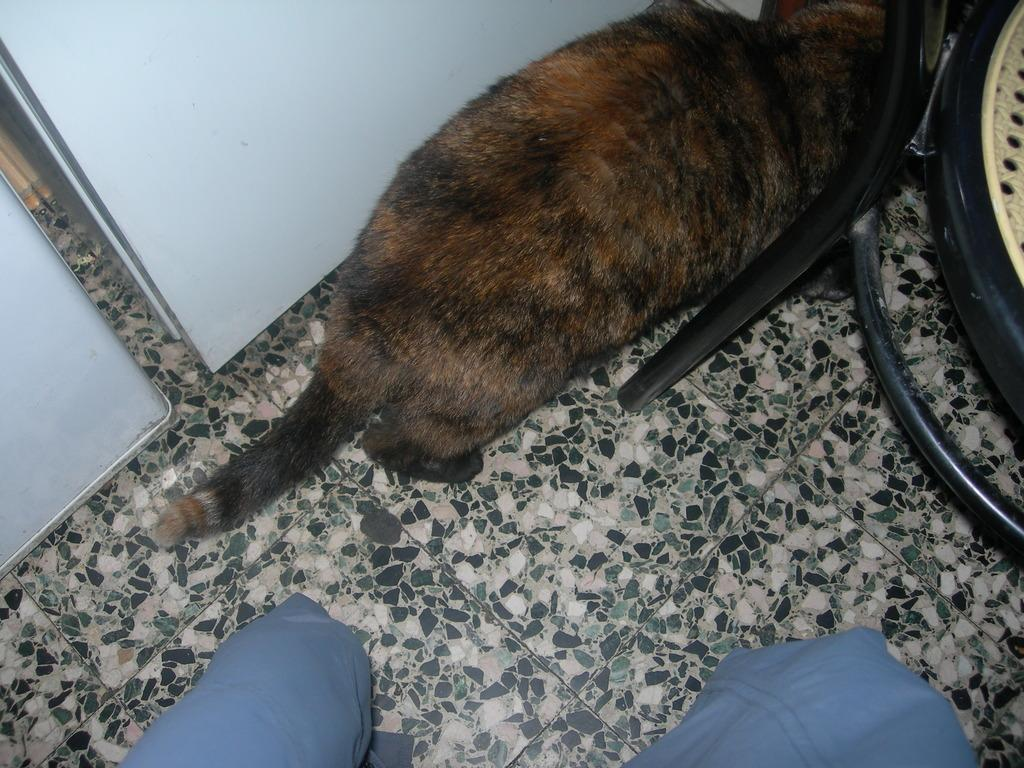What type of animal is present in the image? There is a cat in the image. What piece of furniture can be seen in the image? There is a chair in the image. Is the cat pulling a carriage in the image? No, there is no carriage present in the image, and the cat is not performing any actions related to a carriage. 